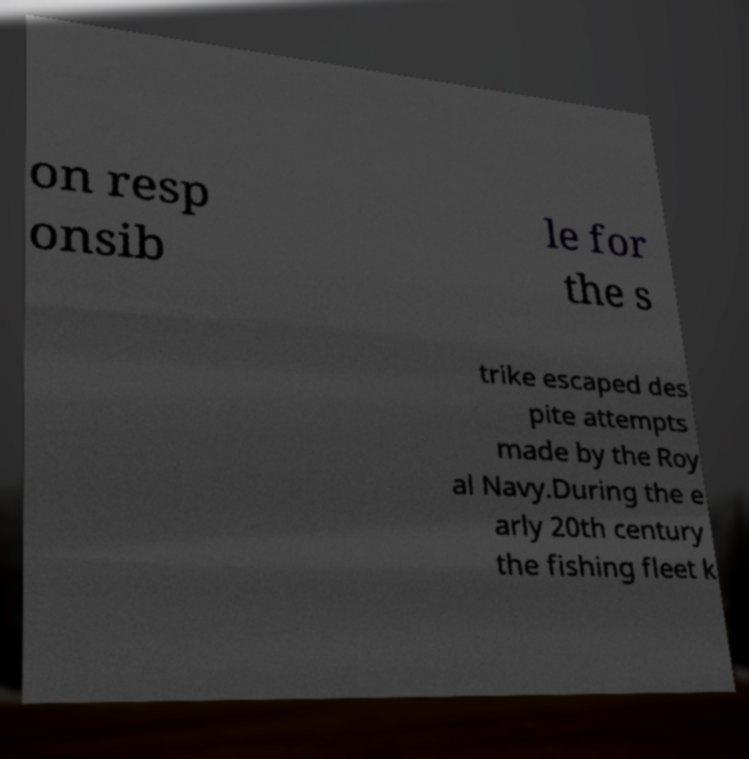Please identify and transcribe the text found in this image. on resp onsib le for the s trike escaped des pite attempts made by the Roy al Navy.During the e arly 20th century the fishing fleet k 